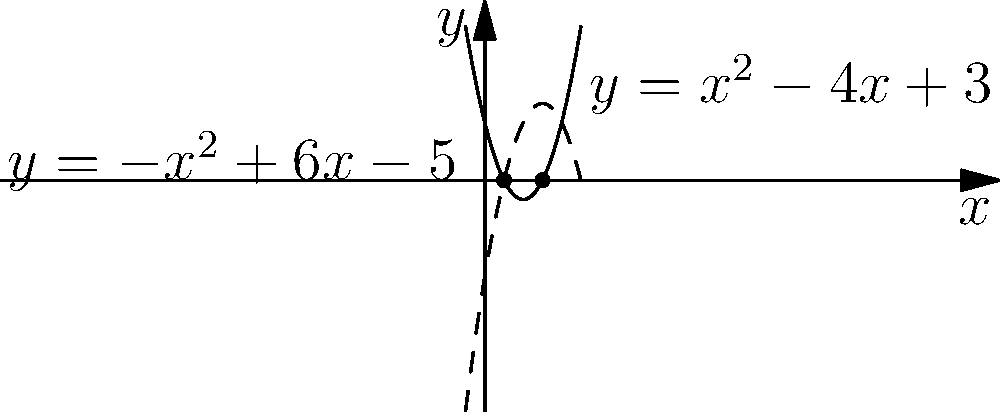In a world where privacy is increasingly scarce, consider two parabolas that intersect, much like how different news stories can overlap. The first parabola is given by the equation $y = x^2 - 4x + 3$, and the second by $y = -x^2 + 6x - 5$. Determine the $x$-coordinates of their intersection points, which represent the moments where these stories converge. To find the intersection points, we need to solve the equation where both parabolas have the same $y$ value:

1) Set the equations equal to each other:
   $x^2 - 4x + 3 = -x^2 + 6x - 5$

2) Rearrange all terms to one side:
   $2x^2 - 10x + 8 = 0$

3) This is a quadratic equation. We can solve it using the quadratic formula: 
   $x = \frac{-b \pm \sqrt{b^2 - 4ac}}{2a}$

   Where $a = 2$, $b = -10$, and $c = 8$

4) Substituting these values:
   $x = \frac{10 \pm \sqrt{100 - 64}}{4} = \frac{10 \pm \sqrt{36}}{4} = \frac{10 \pm 6}{4}$

5) This gives us two solutions:
   $x_1 = \frac{10 + 6}{4} = \frac{16}{4} = 4$
   $x_2 = \frac{10 - 6}{4} = \frac{4}{4} = 1$

Therefore, the parabolas intersect at $x = 1$ and $x = 4$.
Answer: $x = 1$ and $x = 4$ 